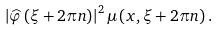Convert formula to latex. <formula><loc_0><loc_0><loc_500><loc_500>\left | \widehat { \varphi } \left ( \xi + 2 \pi n \right ) \right | ^ { 2 } \mu \left ( x , \xi + 2 \pi n \right ) .</formula> 